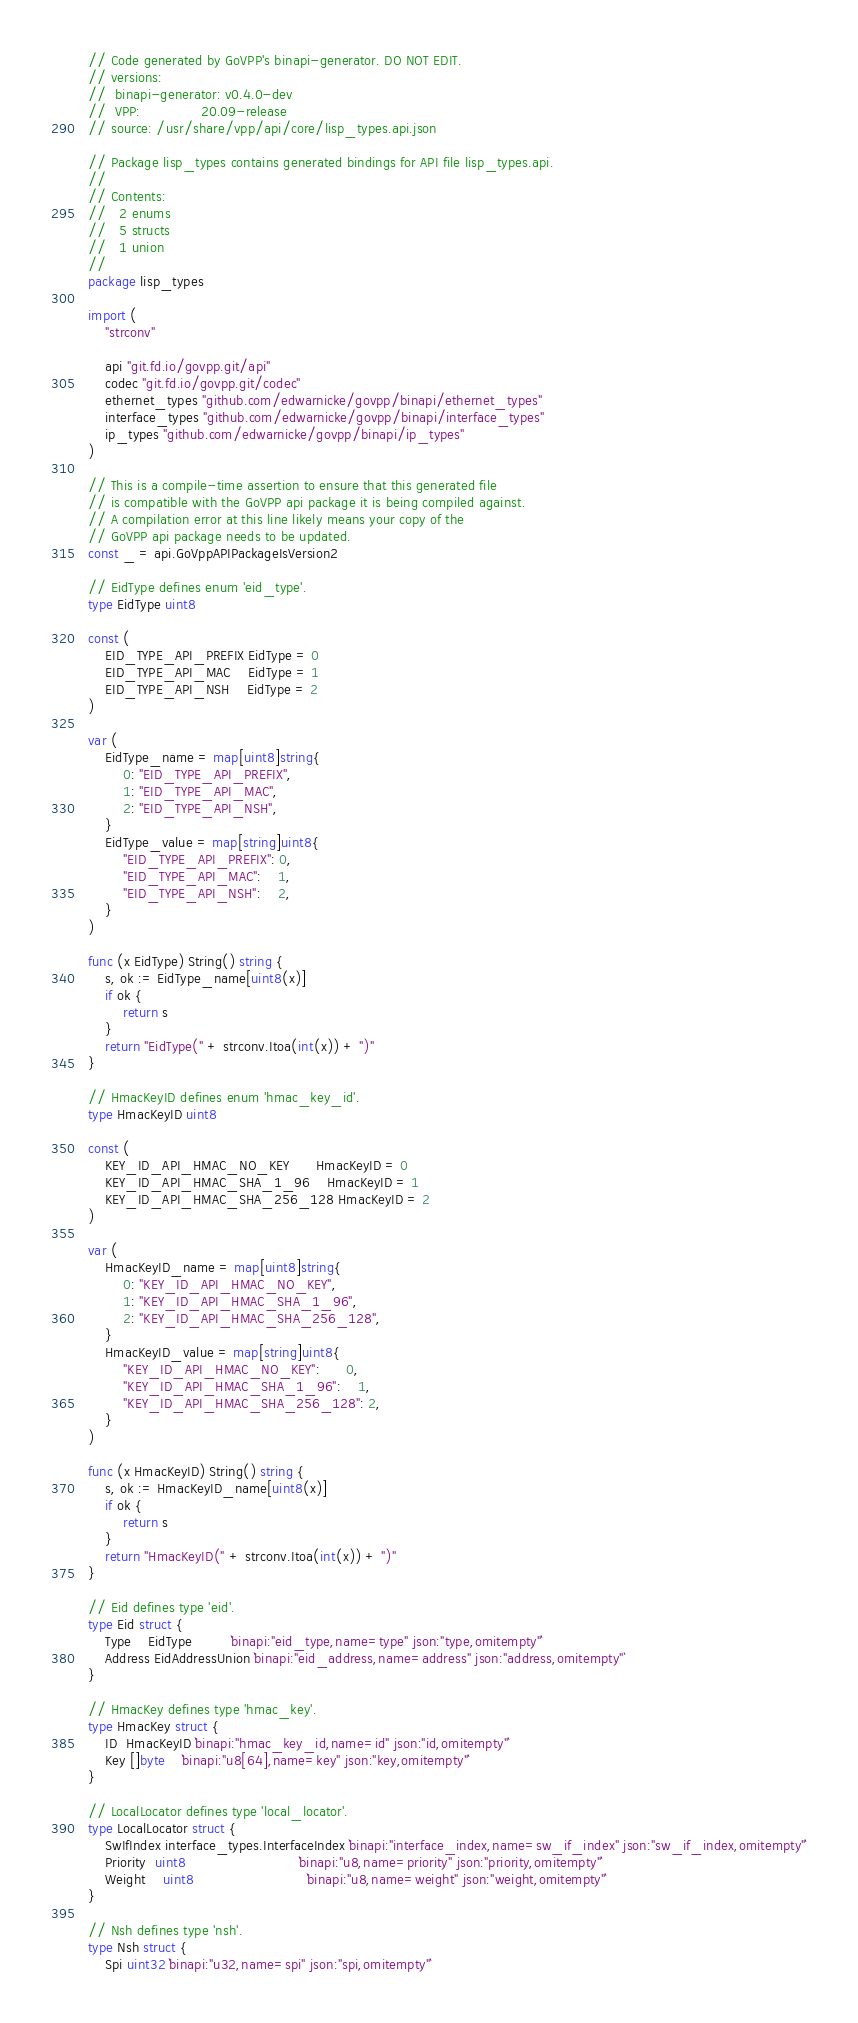<code> <loc_0><loc_0><loc_500><loc_500><_Go_>// Code generated by GoVPP's binapi-generator. DO NOT EDIT.
// versions:
//  binapi-generator: v0.4.0-dev
//  VPP:              20.09-release
// source: /usr/share/vpp/api/core/lisp_types.api.json

// Package lisp_types contains generated bindings for API file lisp_types.api.
//
// Contents:
//   2 enums
//   5 structs
//   1 union
//
package lisp_types

import (
	"strconv"

	api "git.fd.io/govpp.git/api"
	codec "git.fd.io/govpp.git/codec"
	ethernet_types "github.com/edwarnicke/govpp/binapi/ethernet_types"
	interface_types "github.com/edwarnicke/govpp/binapi/interface_types"
	ip_types "github.com/edwarnicke/govpp/binapi/ip_types"
)

// This is a compile-time assertion to ensure that this generated file
// is compatible with the GoVPP api package it is being compiled against.
// A compilation error at this line likely means your copy of the
// GoVPP api package needs to be updated.
const _ = api.GoVppAPIPackageIsVersion2

// EidType defines enum 'eid_type'.
type EidType uint8

const (
	EID_TYPE_API_PREFIX EidType = 0
	EID_TYPE_API_MAC    EidType = 1
	EID_TYPE_API_NSH    EidType = 2
)

var (
	EidType_name = map[uint8]string{
		0: "EID_TYPE_API_PREFIX",
		1: "EID_TYPE_API_MAC",
		2: "EID_TYPE_API_NSH",
	}
	EidType_value = map[string]uint8{
		"EID_TYPE_API_PREFIX": 0,
		"EID_TYPE_API_MAC":    1,
		"EID_TYPE_API_NSH":    2,
	}
)

func (x EidType) String() string {
	s, ok := EidType_name[uint8(x)]
	if ok {
		return s
	}
	return "EidType(" + strconv.Itoa(int(x)) + ")"
}

// HmacKeyID defines enum 'hmac_key_id'.
type HmacKeyID uint8

const (
	KEY_ID_API_HMAC_NO_KEY      HmacKeyID = 0
	KEY_ID_API_HMAC_SHA_1_96    HmacKeyID = 1
	KEY_ID_API_HMAC_SHA_256_128 HmacKeyID = 2
)

var (
	HmacKeyID_name = map[uint8]string{
		0: "KEY_ID_API_HMAC_NO_KEY",
		1: "KEY_ID_API_HMAC_SHA_1_96",
		2: "KEY_ID_API_HMAC_SHA_256_128",
	}
	HmacKeyID_value = map[string]uint8{
		"KEY_ID_API_HMAC_NO_KEY":      0,
		"KEY_ID_API_HMAC_SHA_1_96":    1,
		"KEY_ID_API_HMAC_SHA_256_128": 2,
	}
)

func (x HmacKeyID) String() string {
	s, ok := HmacKeyID_name[uint8(x)]
	if ok {
		return s
	}
	return "HmacKeyID(" + strconv.Itoa(int(x)) + ")"
}

// Eid defines type 'eid'.
type Eid struct {
	Type    EidType         `binapi:"eid_type,name=type" json:"type,omitempty"`
	Address EidAddressUnion `binapi:"eid_address,name=address" json:"address,omitempty"`
}

// HmacKey defines type 'hmac_key'.
type HmacKey struct {
	ID  HmacKeyID `binapi:"hmac_key_id,name=id" json:"id,omitempty"`
	Key []byte    `binapi:"u8[64],name=key" json:"key,omitempty"`
}

// LocalLocator defines type 'local_locator'.
type LocalLocator struct {
	SwIfIndex interface_types.InterfaceIndex `binapi:"interface_index,name=sw_if_index" json:"sw_if_index,omitempty"`
	Priority  uint8                          `binapi:"u8,name=priority" json:"priority,omitempty"`
	Weight    uint8                          `binapi:"u8,name=weight" json:"weight,omitempty"`
}

// Nsh defines type 'nsh'.
type Nsh struct {
	Spi uint32 `binapi:"u32,name=spi" json:"spi,omitempty"`</code> 